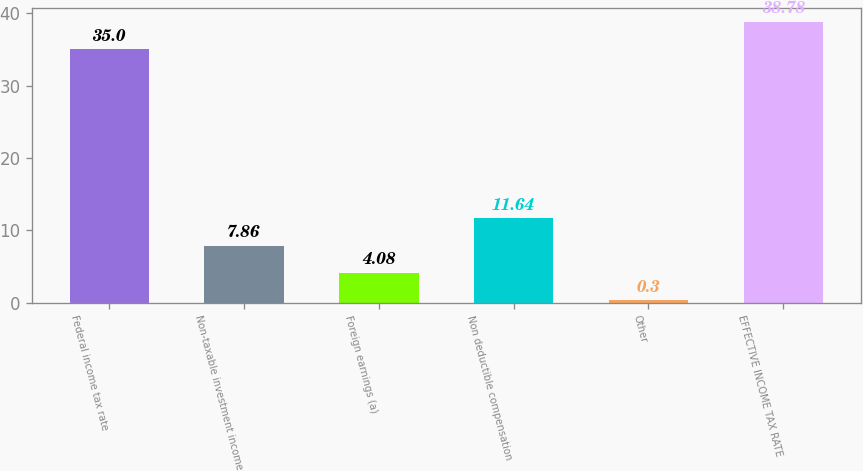<chart> <loc_0><loc_0><loc_500><loc_500><bar_chart><fcel>Federal income tax rate<fcel>Non-taxable investment income<fcel>Foreign earnings (a)<fcel>Non deductible compensation<fcel>Other<fcel>EFFECTIVE INCOME TAX RATE<nl><fcel>35<fcel>7.86<fcel>4.08<fcel>11.64<fcel>0.3<fcel>38.78<nl></chart> 